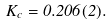<formula> <loc_0><loc_0><loc_500><loc_500>K _ { c } = 0 . 2 0 6 ( 2 ) .</formula> 